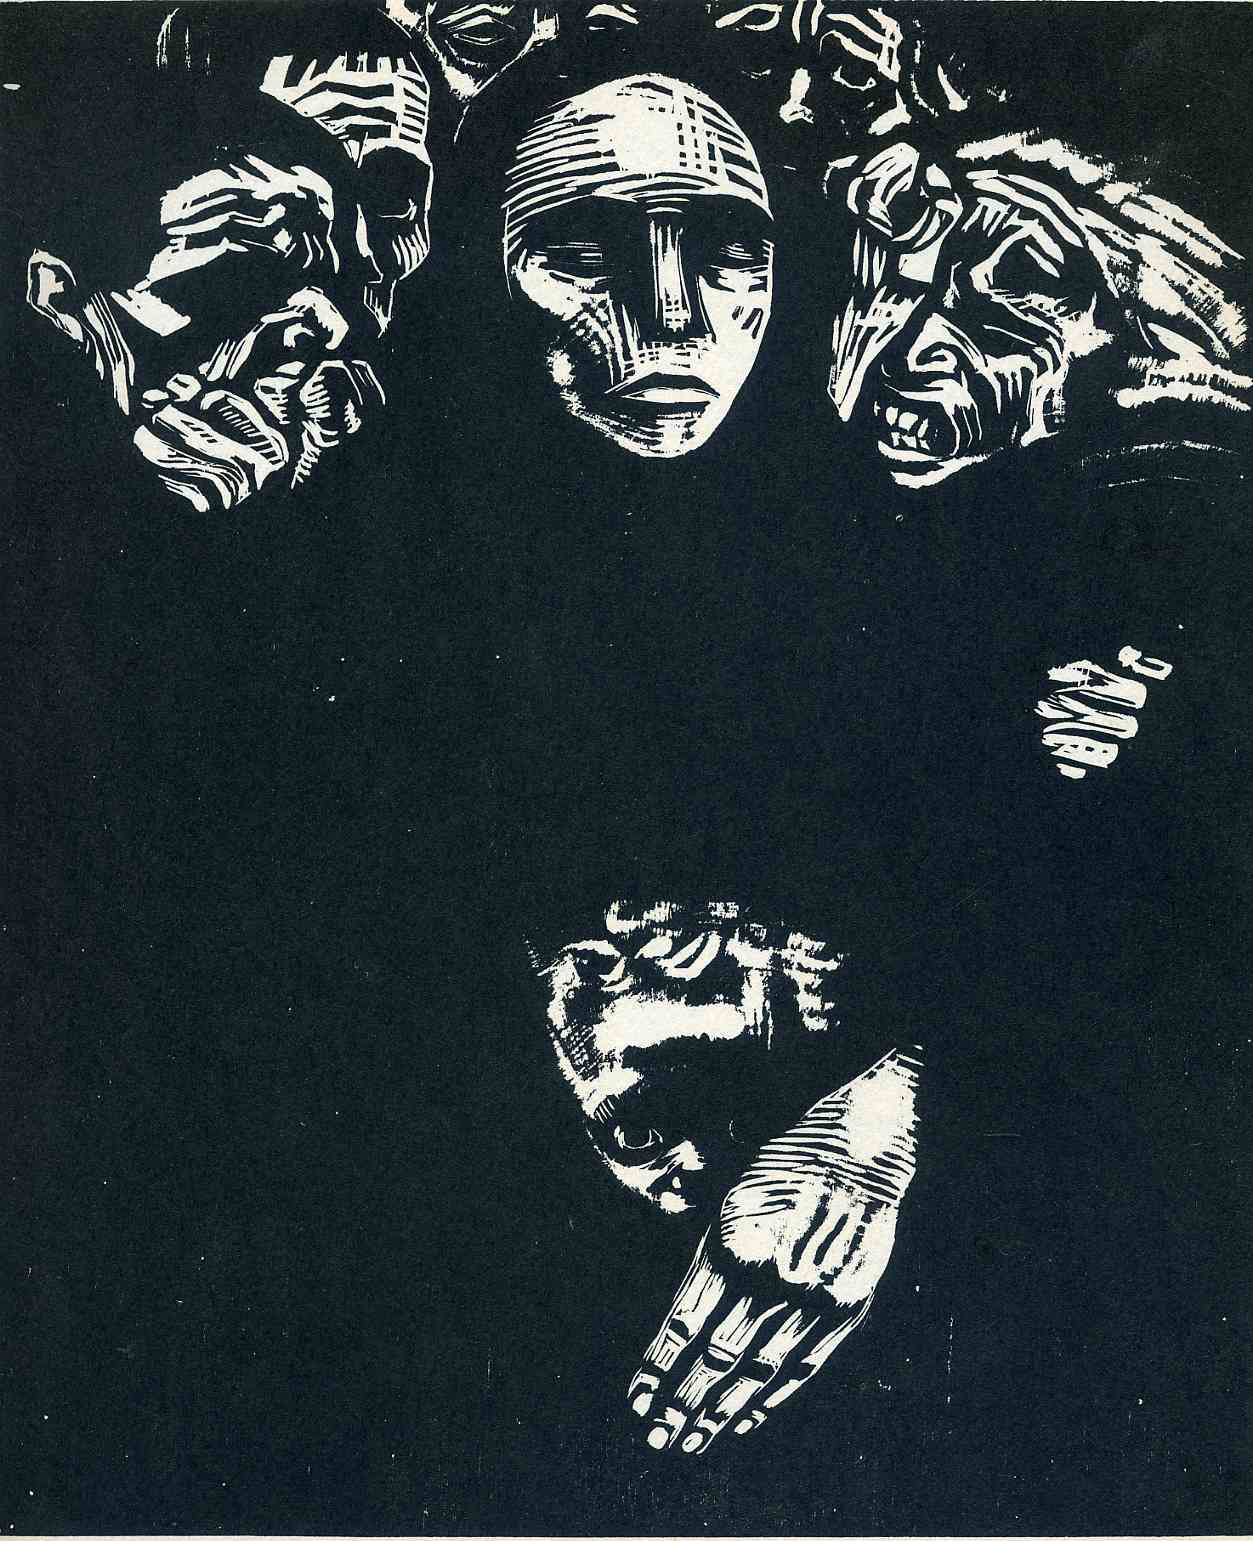Can you elaborate on the elements of the picture provided?
 The image is a striking piece of black and white art that captures the viewer's attention with its surrealistic style. The central focus is a large face, surrounded by a group of smaller faces arranged in a circular pattern. This arrangement gives the impression of a multitude of perspectives converging on a single point of interest. 

Below the faces, a collection of hands is depicted. One hand in particular reaches upwards, as if striving to connect with the faces above. The positioning of the hands adds a dynamic element to the composition, creating a sense of movement and interaction.

The art style is reminiscent of woodcut prints, characterized by bold lines and high contrast. This technique enhances the dramatic effect of the image, emphasizing the distinct shapes and patterns. The genre of the art can be identified as surrealism, given the dreamlike and unusual arrangement of the faces and hands. 

Overall, the image presents a captivating visual narrative, inviting viewers to delve into its intricate details and interpret its symbolic meaning. 